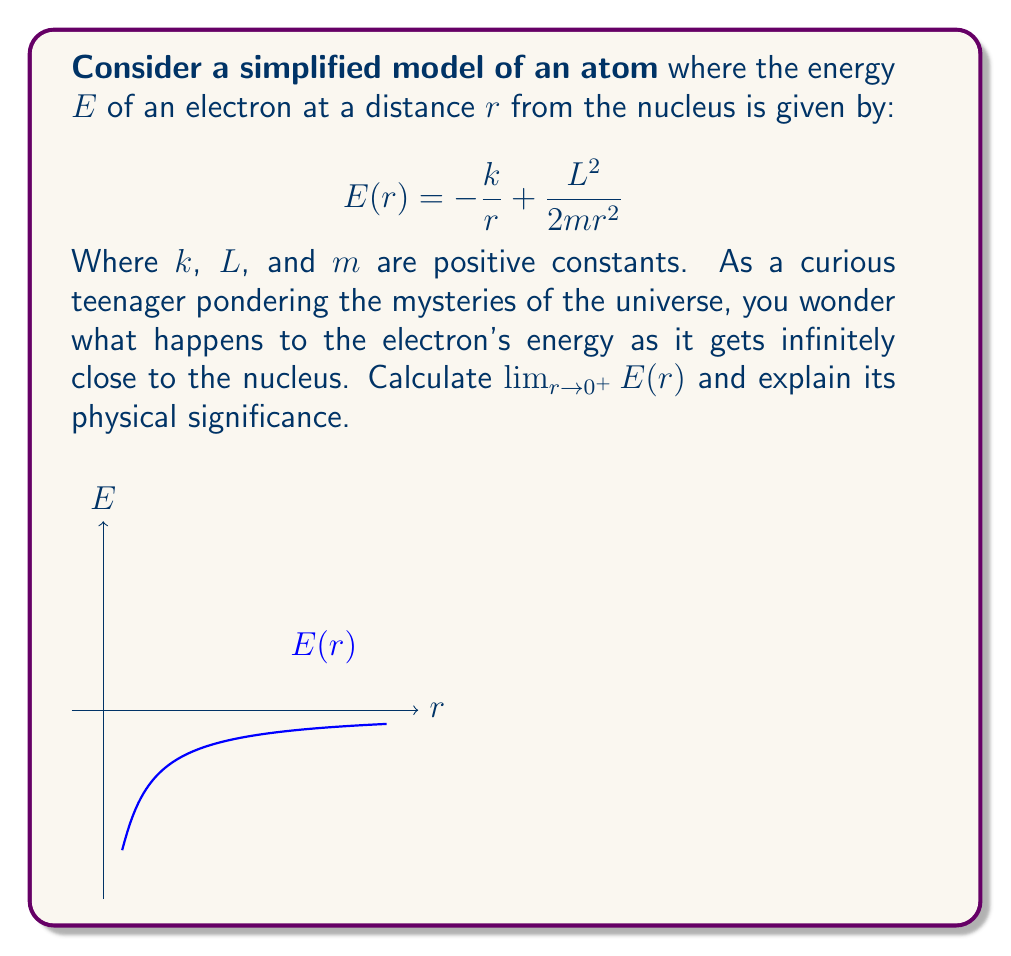Show me your answer to this math problem. Let's approach this step-by-step:

1) We need to evaluate $\lim_{r \to 0^+} E(r)$ where $E(r) = -\frac{k}{r} + \frac{L^2}{2mr^2}$

2) As $r$ approaches 0 from the right (denoted by $0^+$), we need to consider the behavior of each term:

   a) For $-\frac{k}{r}$: As $r \to 0^+$, $\frac{1}{r} \to +\infty$, so $-\frac{k}{r} \to -\infty$
   
   b) For $\frac{L^2}{2mr^2}$: As $r \to 0^+$, $\frac{1}{r^2} \to +\infty$, so $\frac{L^2}{2mr^2} \to +\infty$

3) Now we have a limit of the form $(-\infty) + (+\infty)$, which is indeterminate.

4) To resolve this, let's factor out $\frac{1}{r^2}$:

   $E(r) = \frac{1}{r^2}(-kr + \frac{L^2}{2m})$

5) Now, as $r \to 0^+$, $\frac{1}{r^2} \to +\infty$, and $(-kr + \frac{L^2}{2m}) \to \frac{L^2}{2m}$ (a positive constant)

6) Therefore, $\lim_{r \to 0^+} E(r) = +\infty$

Physical significance: As the electron gets infinitely close to the nucleus, its energy becomes infinitely positive. This implies that it's impossible for the electron to reach the nucleus, as it would require an infinite amount of energy. This aligns with the quantum mechanical model of atoms, where electrons exist in probability clouds rather than definite orbits, and explains why electrons don't "fall" into the nucleus despite the attractive electrostatic force.
Answer: $\lim_{r \to 0^+} E(r) = +\infty$ 